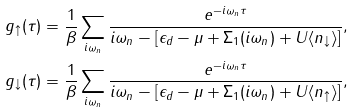Convert formula to latex. <formula><loc_0><loc_0><loc_500><loc_500>& g _ { \uparrow } ( \tau ) = \frac { 1 } { \beta } \sum _ { i \omega _ { n } } \frac { e ^ { - i \omega _ { n } \tau } } { i \omega _ { n } - [ \epsilon _ { d } - \mu + \Sigma _ { 1 } ( i \omega _ { n } ) + U \langle { n _ { \downarrow } } \rangle ] } , \\ & g _ { \downarrow } ( \tau ) = \frac { 1 } { \beta } \sum _ { i \omega _ { n } } \frac { e ^ { - i \omega _ { n } \tau } } { i \omega _ { n } - [ \epsilon _ { d } - \mu + \Sigma _ { 1 } ( i \omega _ { n } ) + U \langle { n _ { \uparrow } } \rangle ] } ,</formula> 